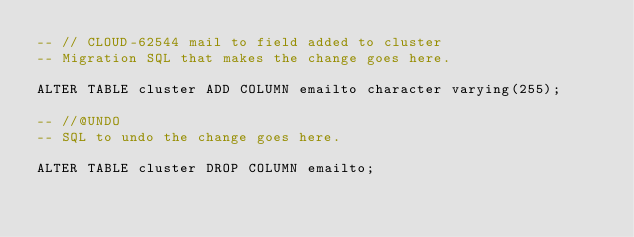Convert code to text. <code><loc_0><loc_0><loc_500><loc_500><_SQL_>-- // CLOUD-62544 mail to field added to cluster
-- Migration SQL that makes the change goes here.

ALTER TABLE cluster ADD COLUMN emailto character varying(255);

-- //@UNDO
-- SQL to undo the change goes here.

ALTER TABLE cluster DROP COLUMN emailto;

</code> 